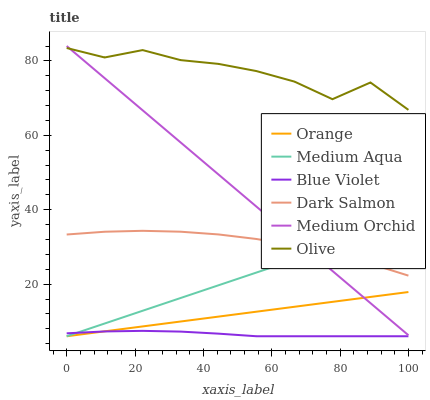Does Blue Violet have the minimum area under the curve?
Answer yes or no. Yes. Does Olive have the maximum area under the curve?
Answer yes or no. Yes. Does Dark Salmon have the minimum area under the curve?
Answer yes or no. No. Does Dark Salmon have the maximum area under the curve?
Answer yes or no. No. Is Orange the smoothest?
Answer yes or no. Yes. Is Olive the roughest?
Answer yes or no. Yes. Is Dark Salmon the smoothest?
Answer yes or no. No. Is Dark Salmon the roughest?
Answer yes or no. No. Does Medium Aqua have the lowest value?
Answer yes or no. Yes. Does Dark Salmon have the lowest value?
Answer yes or no. No. Does Medium Orchid have the highest value?
Answer yes or no. Yes. Does Dark Salmon have the highest value?
Answer yes or no. No. Is Orange less than Olive?
Answer yes or no. Yes. Is Dark Salmon greater than Orange?
Answer yes or no. Yes. Does Blue Violet intersect Medium Aqua?
Answer yes or no. Yes. Is Blue Violet less than Medium Aqua?
Answer yes or no. No. Is Blue Violet greater than Medium Aqua?
Answer yes or no. No. Does Orange intersect Olive?
Answer yes or no. No. 